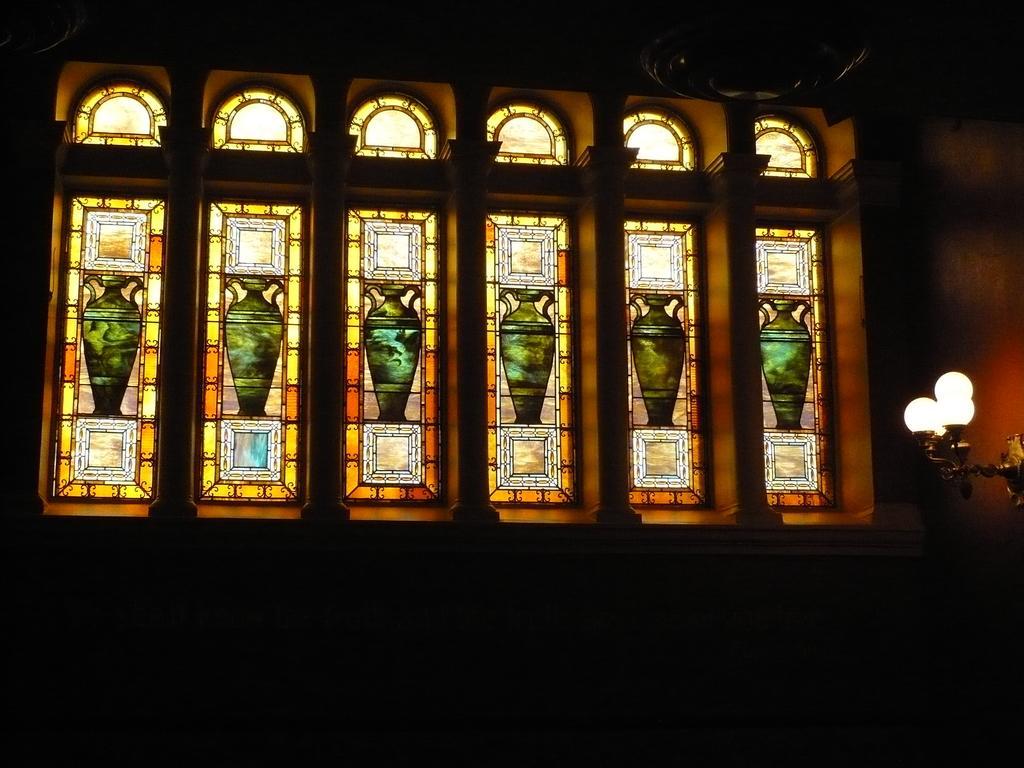Describe this image in one or two sentences. In this image there is a wall having windows. There are pictures painted on the windows. Right side a lamp is attached to the wall. 